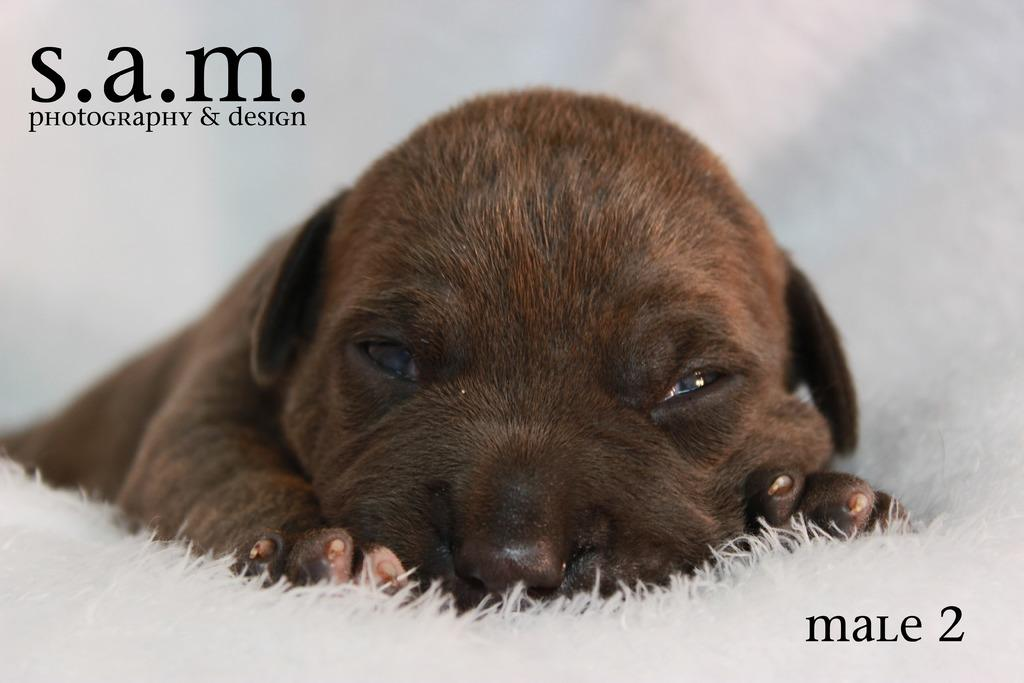What animal is present in the image? There is a dog in the image. What is the dog doing in the image? The dog is sleeping. What is the dog resting on in the image? The dog is on a white color pillow. How many sheep are visible in the image? There are no sheep present in the image; it features a dog sleeping on a white color pillow. 